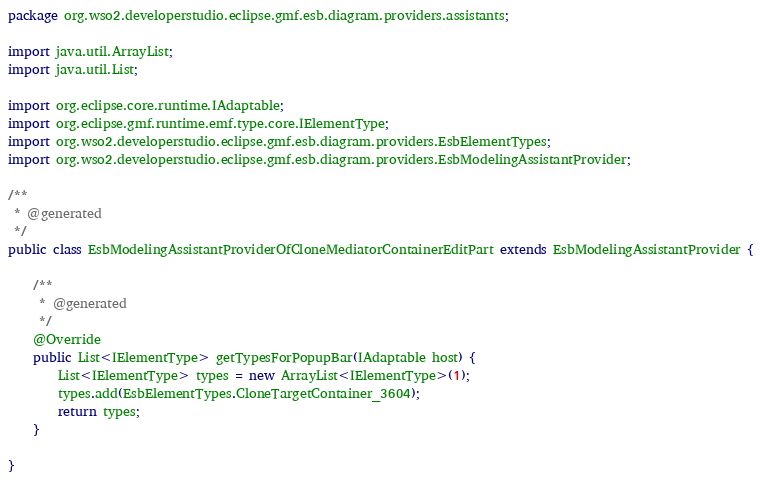<code> <loc_0><loc_0><loc_500><loc_500><_Java_>package org.wso2.developerstudio.eclipse.gmf.esb.diagram.providers.assistants;

import java.util.ArrayList;
import java.util.List;

import org.eclipse.core.runtime.IAdaptable;
import org.eclipse.gmf.runtime.emf.type.core.IElementType;
import org.wso2.developerstudio.eclipse.gmf.esb.diagram.providers.EsbElementTypes;
import org.wso2.developerstudio.eclipse.gmf.esb.diagram.providers.EsbModelingAssistantProvider;

/**
 * @generated
 */
public class EsbModelingAssistantProviderOfCloneMediatorContainerEditPart extends EsbModelingAssistantProvider {

    /**
     * @generated
     */
    @Override
    public List<IElementType> getTypesForPopupBar(IAdaptable host) {
        List<IElementType> types = new ArrayList<IElementType>(1);
        types.add(EsbElementTypes.CloneTargetContainer_3604);
        return types;
    }

}
</code> 